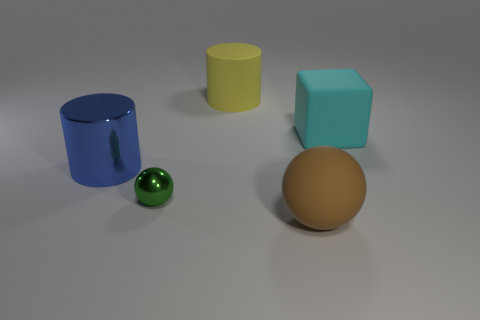Add 4 shiny cylinders. How many objects exist? 9 Subtract all cylinders. How many objects are left? 3 Subtract all tiny green spheres. Subtract all cyan rubber cubes. How many objects are left? 3 Add 1 cyan objects. How many cyan objects are left? 2 Add 2 big yellow balls. How many big yellow balls exist? 2 Subtract 0 green cylinders. How many objects are left? 5 